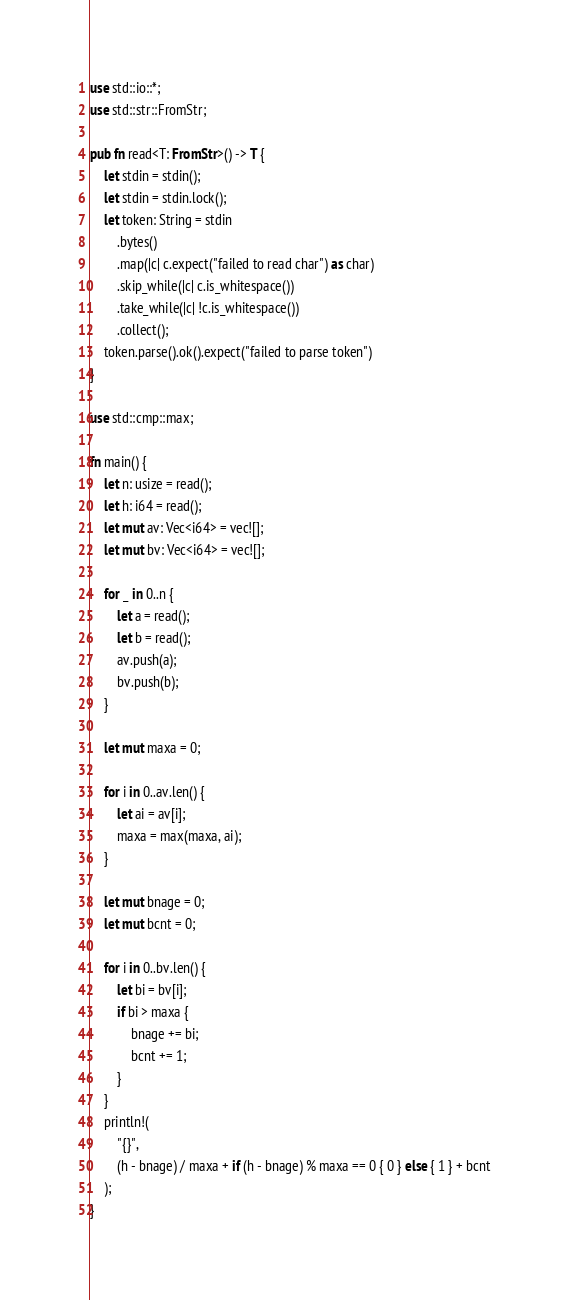Convert code to text. <code><loc_0><loc_0><loc_500><loc_500><_Rust_>use std::io::*;
use std::str::FromStr;

pub fn read<T: FromStr>() -> T {
    let stdin = stdin();
    let stdin = stdin.lock();
    let token: String = stdin
        .bytes()
        .map(|c| c.expect("failed to read char") as char)
        .skip_while(|c| c.is_whitespace())
        .take_while(|c| !c.is_whitespace())
        .collect();
    token.parse().ok().expect("failed to parse token")
}

use std::cmp::max;

fn main() {
    let n: usize = read();
    let h: i64 = read();
    let mut av: Vec<i64> = vec![];
    let mut bv: Vec<i64> = vec![];

    for _ in 0..n {
        let a = read();
        let b = read();
        av.push(a);
        bv.push(b);
    }

    let mut maxa = 0;

    for i in 0..av.len() {
        let ai = av[i];
        maxa = max(maxa, ai);
    }

    let mut bnage = 0;
    let mut bcnt = 0;

    for i in 0..bv.len() {
        let bi = bv[i];
        if bi > maxa {
            bnage += bi;
            bcnt += 1;
        }
    }
    println!(
        "{}",
        (h - bnage) / maxa + if (h - bnage) % maxa == 0 { 0 } else { 1 } + bcnt
    );
}
</code> 